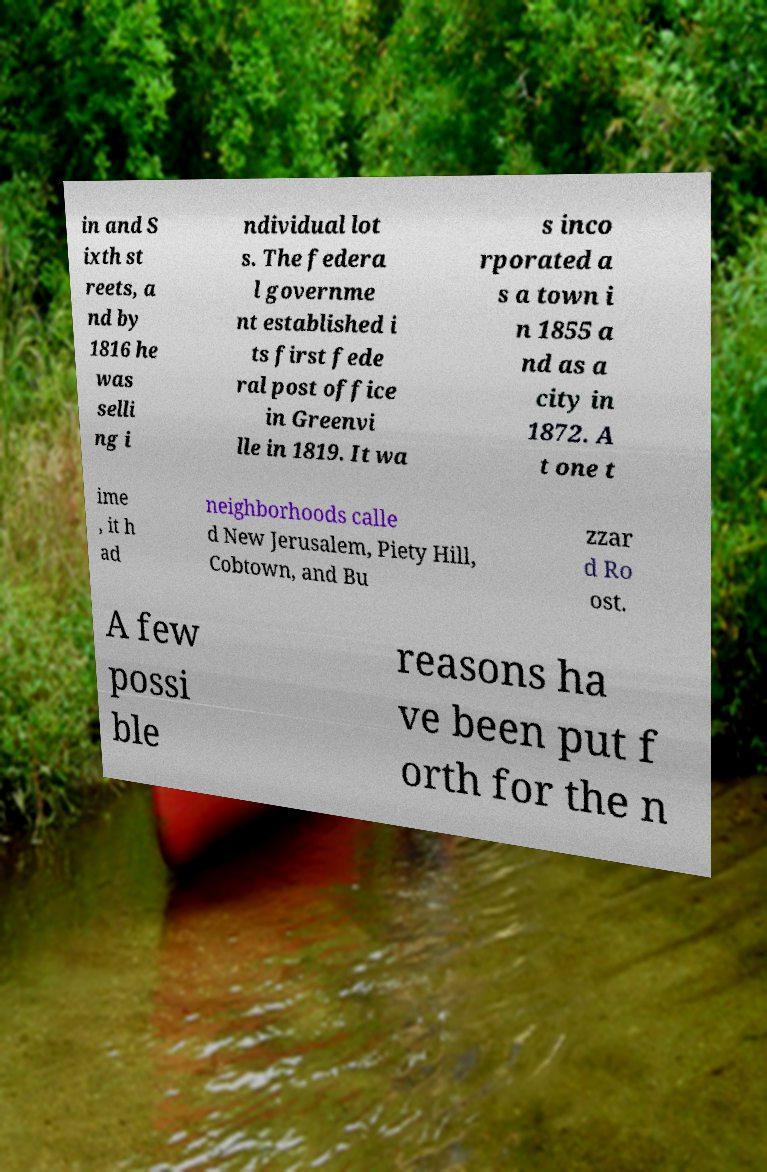What messages or text are displayed in this image? I need them in a readable, typed format. in and S ixth st reets, a nd by 1816 he was selli ng i ndividual lot s. The federa l governme nt established i ts first fede ral post office in Greenvi lle in 1819. It wa s inco rporated a s a town i n 1855 a nd as a city in 1872. A t one t ime , it h ad neighborhoods calle d New Jerusalem, Piety Hill, Cobtown, and Bu zzar d Ro ost. A few possi ble reasons ha ve been put f orth for the n 